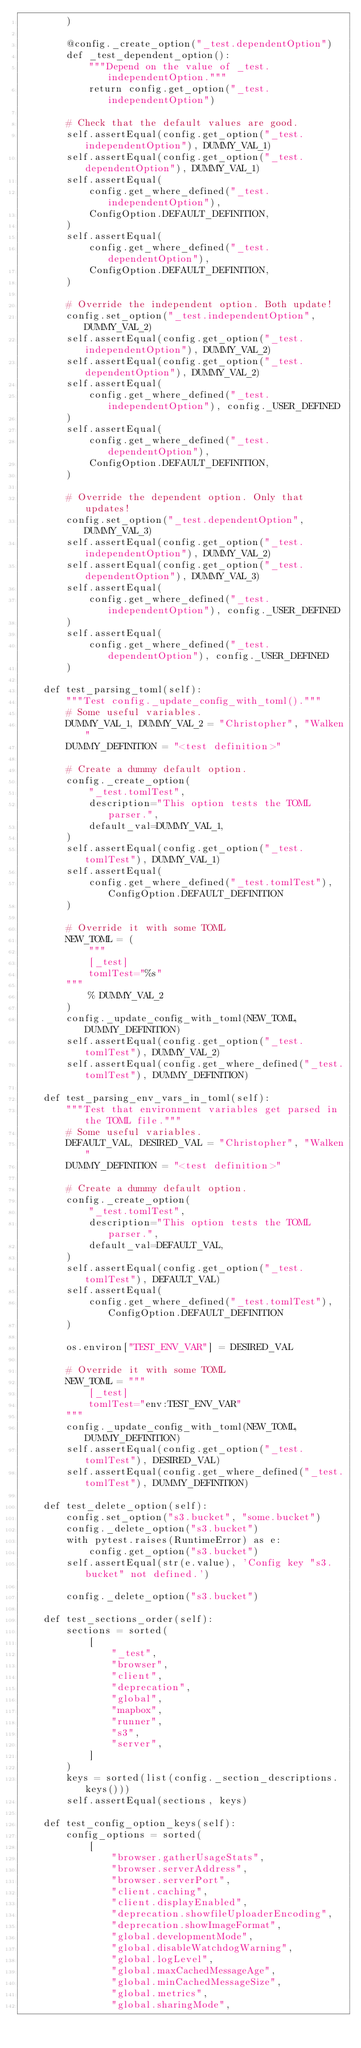Convert code to text. <code><loc_0><loc_0><loc_500><loc_500><_Python_>        )

        @config._create_option("_test.dependentOption")
        def _test_dependent_option():
            """Depend on the value of _test.independentOption."""
            return config.get_option("_test.independentOption")

        # Check that the default values are good.
        self.assertEqual(config.get_option("_test.independentOption"), DUMMY_VAL_1)
        self.assertEqual(config.get_option("_test.dependentOption"), DUMMY_VAL_1)
        self.assertEqual(
            config.get_where_defined("_test.independentOption"),
            ConfigOption.DEFAULT_DEFINITION,
        )
        self.assertEqual(
            config.get_where_defined("_test.dependentOption"),
            ConfigOption.DEFAULT_DEFINITION,
        )

        # Override the independent option. Both update!
        config.set_option("_test.independentOption", DUMMY_VAL_2)
        self.assertEqual(config.get_option("_test.independentOption"), DUMMY_VAL_2)
        self.assertEqual(config.get_option("_test.dependentOption"), DUMMY_VAL_2)
        self.assertEqual(
            config.get_where_defined("_test.independentOption"), config._USER_DEFINED
        )
        self.assertEqual(
            config.get_where_defined("_test.dependentOption"),
            ConfigOption.DEFAULT_DEFINITION,
        )

        # Override the dependent option. Only that updates!
        config.set_option("_test.dependentOption", DUMMY_VAL_3)
        self.assertEqual(config.get_option("_test.independentOption"), DUMMY_VAL_2)
        self.assertEqual(config.get_option("_test.dependentOption"), DUMMY_VAL_3)
        self.assertEqual(
            config.get_where_defined("_test.independentOption"), config._USER_DEFINED
        )
        self.assertEqual(
            config.get_where_defined("_test.dependentOption"), config._USER_DEFINED
        )

    def test_parsing_toml(self):
        """Test config._update_config_with_toml()."""
        # Some useful variables.
        DUMMY_VAL_1, DUMMY_VAL_2 = "Christopher", "Walken"
        DUMMY_DEFINITION = "<test definition>"

        # Create a dummy default option.
        config._create_option(
            "_test.tomlTest",
            description="This option tests the TOML parser.",
            default_val=DUMMY_VAL_1,
        )
        self.assertEqual(config.get_option("_test.tomlTest"), DUMMY_VAL_1)
        self.assertEqual(
            config.get_where_defined("_test.tomlTest"), ConfigOption.DEFAULT_DEFINITION
        )

        # Override it with some TOML
        NEW_TOML = (
            """
            [_test]
            tomlTest="%s"
        """
            % DUMMY_VAL_2
        )
        config._update_config_with_toml(NEW_TOML, DUMMY_DEFINITION)
        self.assertEqual(config.get_option("_test.tomlTest"), DUMMY_VAL_2)
        self.assertEqual(config.get_where_defined("_test.tomlTest"), DUMMY_DEFINITION)

    def test_parsing_env_vars_in_toml(self):
        """Test that environment variables get parsed in the TOML file."""
        # Some useful variables.
        DEFAULT_VAL, DESIRED_VAL = "Christopher", "Walken"
        DUMMY_DEFINITION = "<test definition>"

        # Create a dummy default option.
        config._create_option(
            "_test.tomlTest",
            description="This option tests the TOML parser.",
            default_val=DEFAULT_VAL,
        )
        self.assertEqual(config.get_option("_test.tomlTest"), DEFAULT_VAL)
        self.assertEqual(
            config.get_where_defined("_test.tomlTest"), ConfigOption.DEFAULT_DEFINITION
        )

        os.environ["TEST_ENV_VAR"] = DESIRED_VAL

        # Override it with some TOML
        NEW_TOML = """
            [_test]
            tomlTest="env:TEST_ENV_VAR"
        """
        config._update_config_with_toml(NEW_TOML, DUMMY_DEFINITION)
        self.assertEqual(config.get_option("_test.tomlTest"), DESIRED_VAL)
        self.assertEqual(config.get_where_defined("_test.tomlTest"), DUMMY_DEFINITION)

    def test_delete_option(self):
        config.set_option("s3.bucket", "some.bucket")
        config._delete_option("s3.bucket")
        with pytest.raises(RuntimeError) as e:
            config.get_option("s3.bucket")
        self.assertEqual(str(e.value), 'Config key "s3.bucket" not defined.')

        config._delete_option("s3.bucket")

    def test_sections_order(self):
        sections = sorted(
            [
                "_test",
                "browser",
                "client",
                "deprecation",
                "global",
                "mapbox",
                "runner",
                "s3",
                "server",
            ]
        )
        keys = sorted(list(config._section_descriptions.keys()))
        self.assertEqual(sections, keys)

    def test_config_option_keys(self):
        config_options = sorted(
            [
                "browser.gatherUsageStats",
                "browser.serverAddress",
                "browser.serverPort",
                "client.caching",
                "client.displayEnabled",
                "deprecation.showfileUploaderEncoding",
                "deprecation.showImageFormat",
                "global.developmentMode",
                "global.disableWatchdogWarning",
                "global.logLevel",
                "global.maxCachedMessageAge",
                "global.minCachedMessageSize",
                "global.metrics",
                "global.sharingMode",</code> 